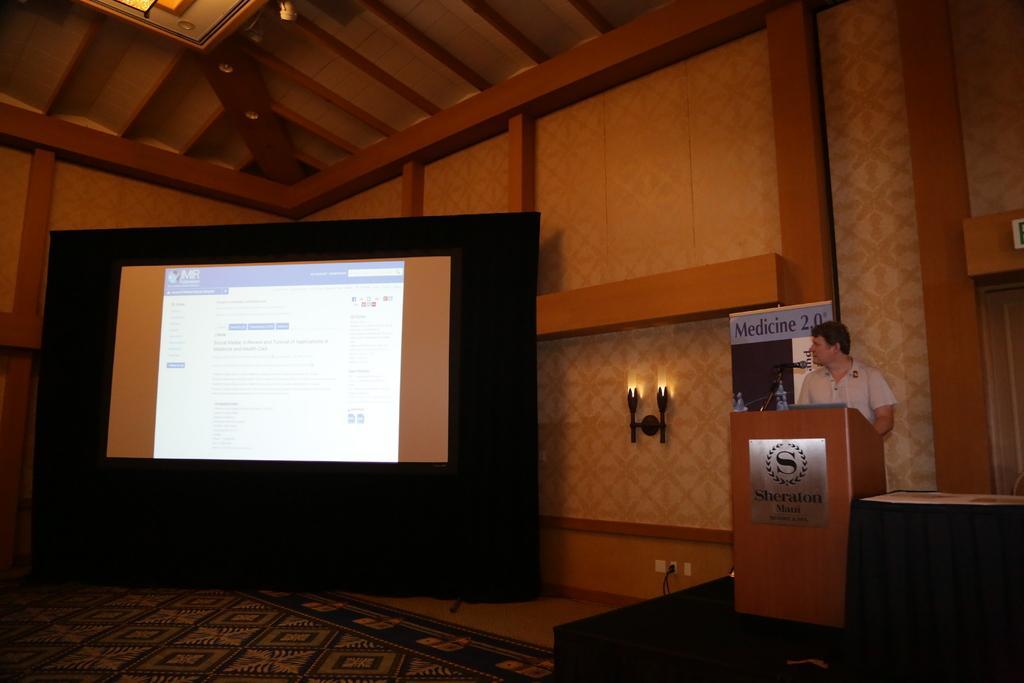Describe this image in one or two sentences. In this image we can see walls, lights attached to the wall, display screen, carpet, floor, cable, power notch, person standing near the podium, disposal bottle and an information board. 